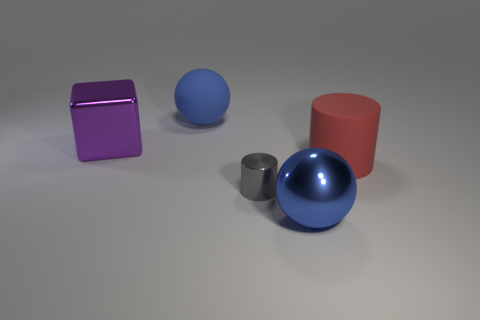What number of other objects are there of the same shape as the large purple metal object?
Give a very brief answer. 0. The large thing that is on the right side of the big purple shiny cube and to the left of the gray metallic cylinder is what color?
Your answer should be very brief. Blue. There is a rubber object behind the big rubber object that is in front of the big blue matte thing; what size is it?
Give a very brief answer. Large. Is there a thing of the same color as the big rubber sphere?
Ensure brevity in your answer.  Yes. Are there an equal number of large purple shiny blocks that are behind the blue rubber sphere and red metal spheres?
Offer a very short reply. Yes. How many large brown rubber balls are there?
Provide a succinct answer. 0. There is a object that is to the left of the blue shiny ball and in front of the red object; what is its shape?
Make the answer very short. Cylinder. Is the color of the large metallic thing that is in front of the tiny metallic cylinder the same as the thing that is behind the purple shiny cube?
Offer a very short reply. Yes. There is another sphere that is the same color as the big rubber ball; what is its size?
Provide a succinct answer. Large. Are there any large cylinders made of the same material as the large purple cube?
Your answer should be very brief. No. 